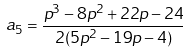<formula> <loc_0><loc_0><loc_500><loc_500>a _ { 5 } = \frac { p ^ { 3 } - 8 p ^ { 2 } + 2 2 p - 2 4 } { 2 ( 5 p ^ { 2 } - 1 9 p - 4 ) }</formula> 